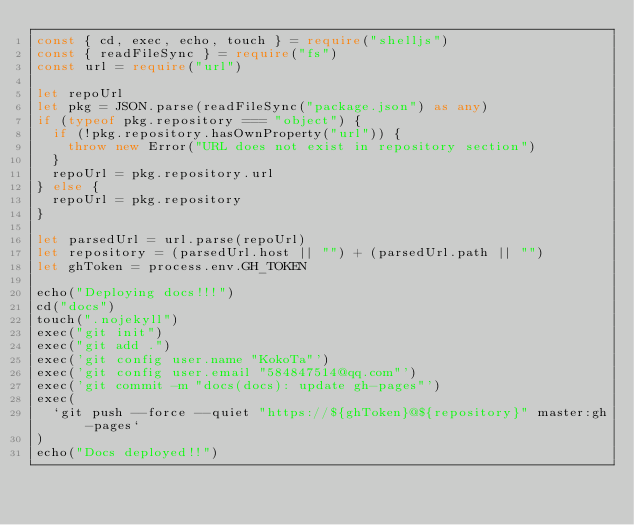<code> <loc_0><loc_0><loc_500><loc_500><_TypeScript_>const { cd, exec, echo, touch } = require("shelljs")
const { readFileSync } = require("fs")
const url = require("url")

let repoUrl
let pkg = JSON.parse(readFileSync("package.json") as any)
if (typeof pkg.repository === "object") {
  if (!pkg.repository.hasOwnProperty("url")) {
    throw new Error("URL does not exist in repository section")
  }
  repoUrl = pkg.repository.url
} else {
  repoUrl = pkg.repository
}

let parsedUrl = url.parse(repoUrl)
let repository = (parsedUrl.host || "") + (parsedUrl.path || "")
let ghToken = process.env.GH_TOKEN

echo("Deploying docs!!!")
cd("docs")
touch(".nojekyll")
exec("git init")
exec("git add .")
exec('git config user.name "KokoTa"')
exec('git config user.email "584847514@qq.com"')
exec('git commit -m "docs(docs): update gh-pages"')
exec(
  `git push --force --quiet "https://${ghToken}@${repository}" master:gh-pages`
)
echo("Docs deployed!!")
</code> 